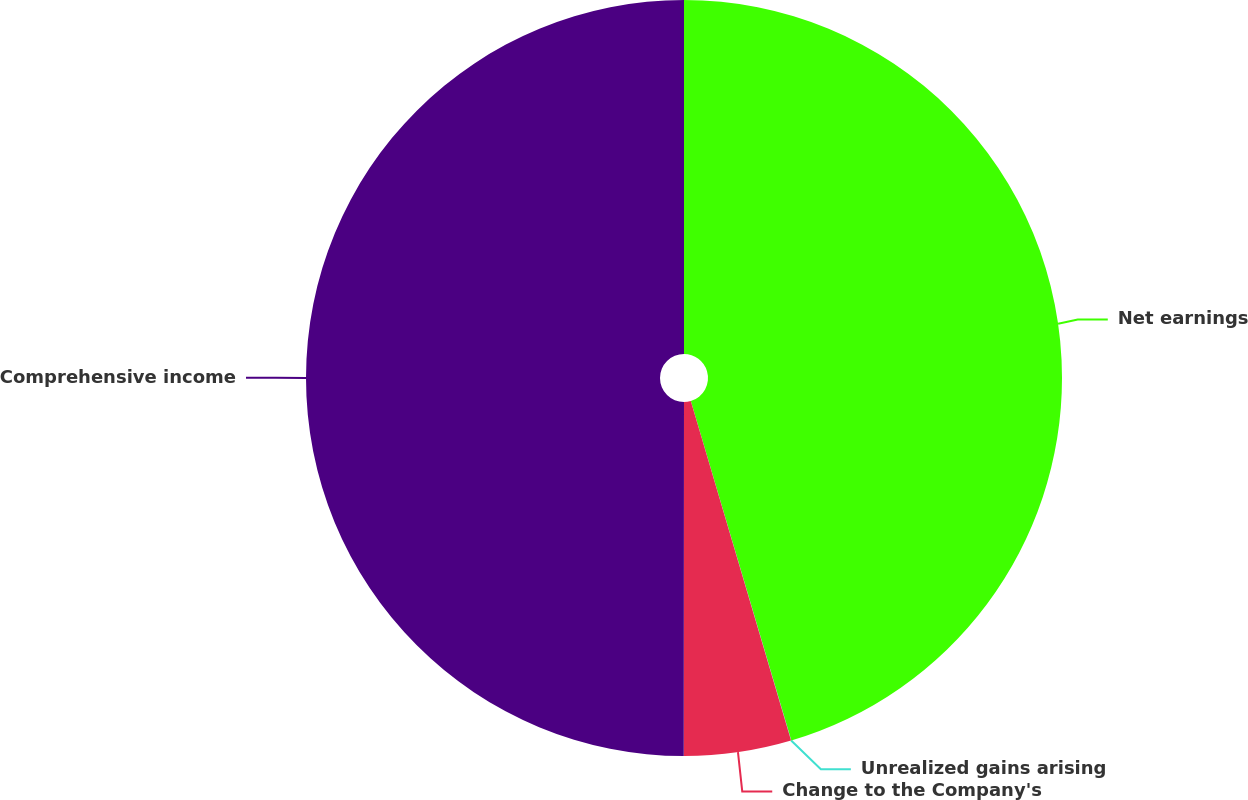Convert chart. <chart><loc_0><loc_0><loc_500><loc_500><pie_chart><fcel>Net earnings<fcel>Unrealized gains arising<fcel>Change to the Company's<fcel>Comprehensive income<nl><fcel>45.42%<fcel>0.01%<fcel>4.58%<fcel>49.99%<nl></chart> 